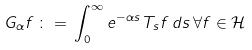<formula> <loc_0><loc_0><loc_500><loc_500>G _ { \alpha } f \, \colon = \, \int _ { 0 } ^ { \infty } e ^ { - \alpha s } \, T _ { s } f \, d s \, \forall f \in { \mathcal { H } }</formula> 